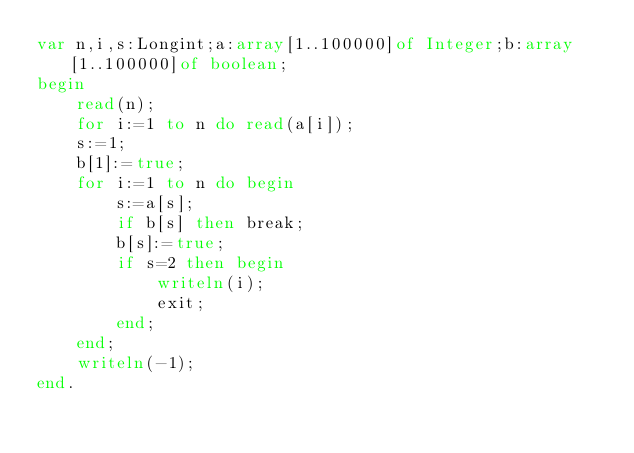<code> <loc_0><loc_0><loc_500><loc_500><_Pascal_>var n,i,s:Longint;a:array[1..100000]of Integer;b:array[1..100000]of boolean;
begin
	read(n);
	for i:=1 to n do read(a[i]);
	s:=1;
	b[1]:=true;
	for i:=1 to n do begin
		s:=a[s];
		if b[s] then break;
		b[s]:=true;
		if s=2 then begin
			writeln(i);
			exit;
		end;
	end;
	writeln(-1);
end.</code> 